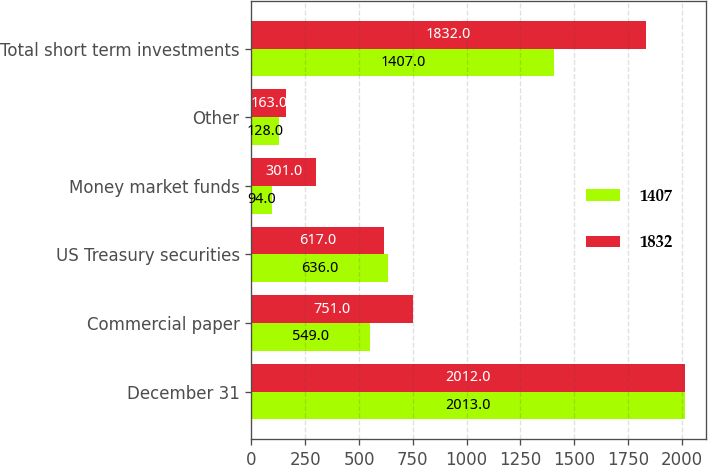Convert chart to OTSL. <chart><loc_0><loc_0><loc_500><loc_500><stacked_bar_chart><ecel><fcel>December 31<fcel>Commercial paper<fcel>US Treasury securities<fcel>Money market funds<fcel>Other<fcel>Total short term investments<nl><fcel>1407<fcel>2013<fcel>549<fcel>636<fcel>94<fcel>128<fcel>1407<nl><fcel>1832<fcel>2012<fcel>751<fcel>617<fcel>301<fcel>163<fcel>1832<nl></chart> 